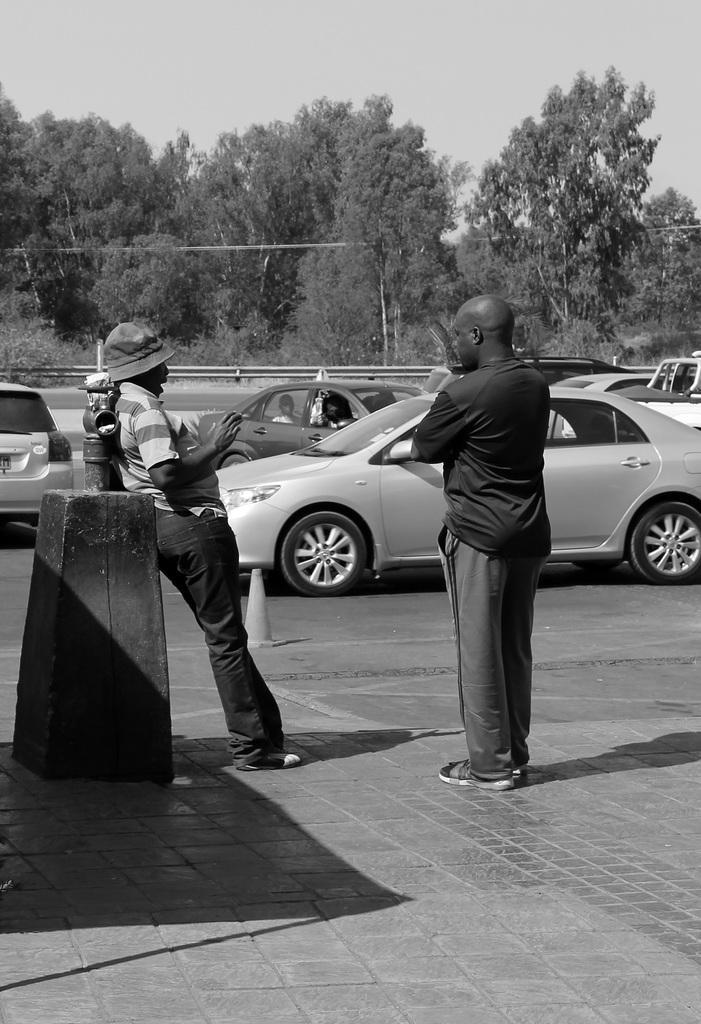In one or two sentences, can you explain what this image depicts? In this image, few peoples are stand at the pillar. And back side, we can see so many vehicles , few are there inside the vehicle. There are so many trees and sky we can see. In the middle, we can see a traffic cone. 